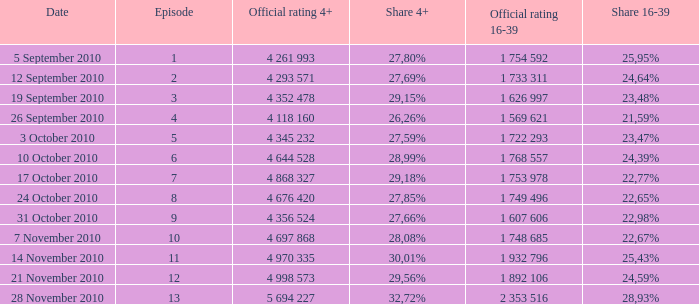What is the official rating 16-39 for the episode with  a 16-39 share of 22,77%? 1 753 978. 